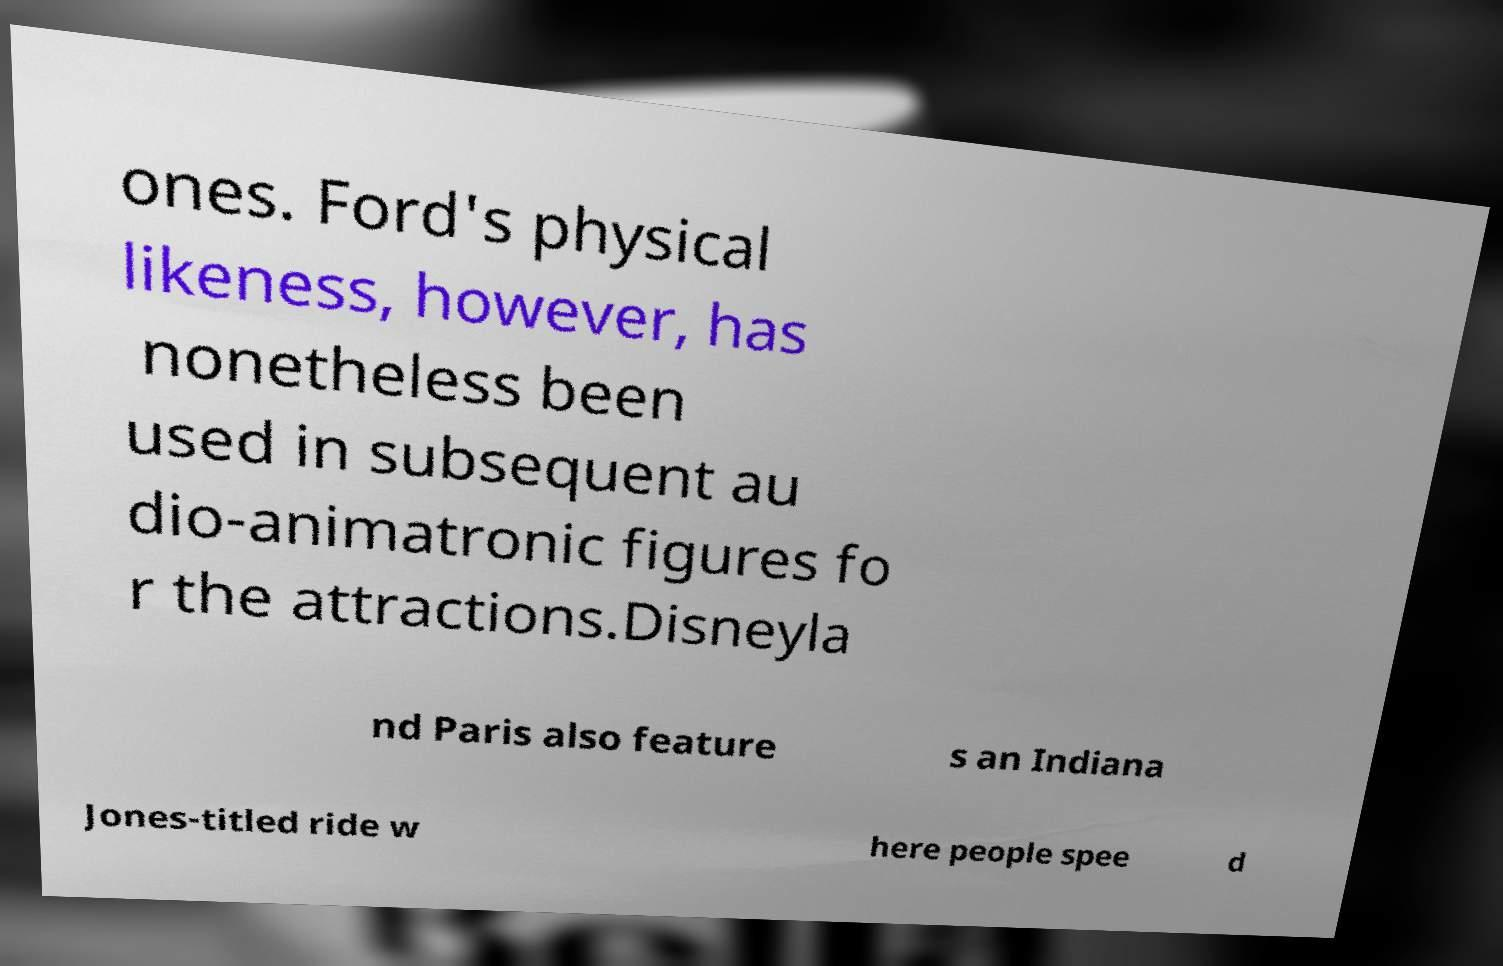Can you read and provide the text displayed in the image?This photo seems to have some interesting text. Can you extract and type it out for me? ones. Ford's physical likeness, however, has nonetheless been used in subsequent au dio-animatronic figures fo r the attractions.Disneyla nd Paris also feature s an Indiana Jones-titled ride w here people spee d 